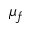<formula> <loc_0><loc_0><loc_500><loc_500>\mu _ { f }</formula> 